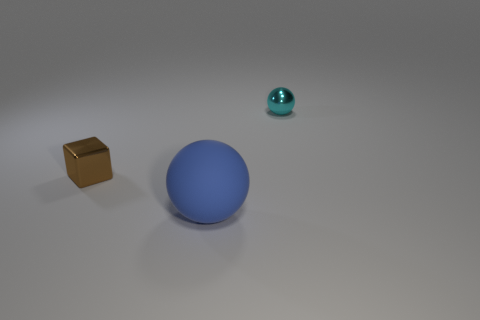There is a tiny sphere; how many large blue rubber things are to the left of it?
Give a very brief answer. 1. What is the material of the object that is both behind the blue ball and to the right of the tiny brown metal cube?
Your answer should be very brief. Metal. What number of tiny objects are either blue objects or green things?
Give a very brief answer. 0. What is the size of the cyan thing?
Offer a very short reply. Small. There is a matte object; what shape is it?
Offer a very short reply. Sphere. Is there anything else that is the same shape as the brown thing?
Ensure brevity in your answer.  No. Is the number of big matte balls that are behind the blue matte object less than the number of blue rubber spheres?
Give a very brief answer. Yes. What number of rubber things are blue spheres or tiny things?
Provide a short and direct response. 1. Are there any other things that have the same size as the blue object?
Your answer should be compact. No. What color is the thing that is made of the same material as the block?
Offer a terse response. Cyan. 